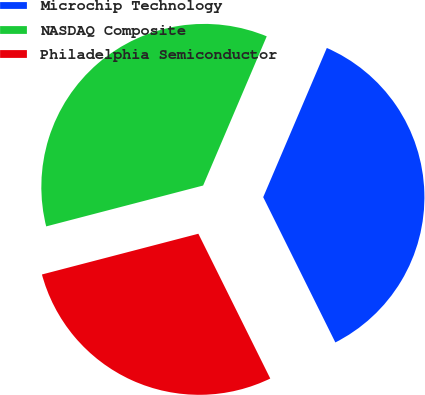Convert chart to OTSL. <chart><loc_0><loc_0><loc_500><loc_500><pie_chart><fcel>Microchip Technology<fcel>NASDAQ Composite<fcel>Philadelphia Semiconductor<nl><fcel>36.25%<fcel>35.47%<fcel>28.28%<nl></chart> 